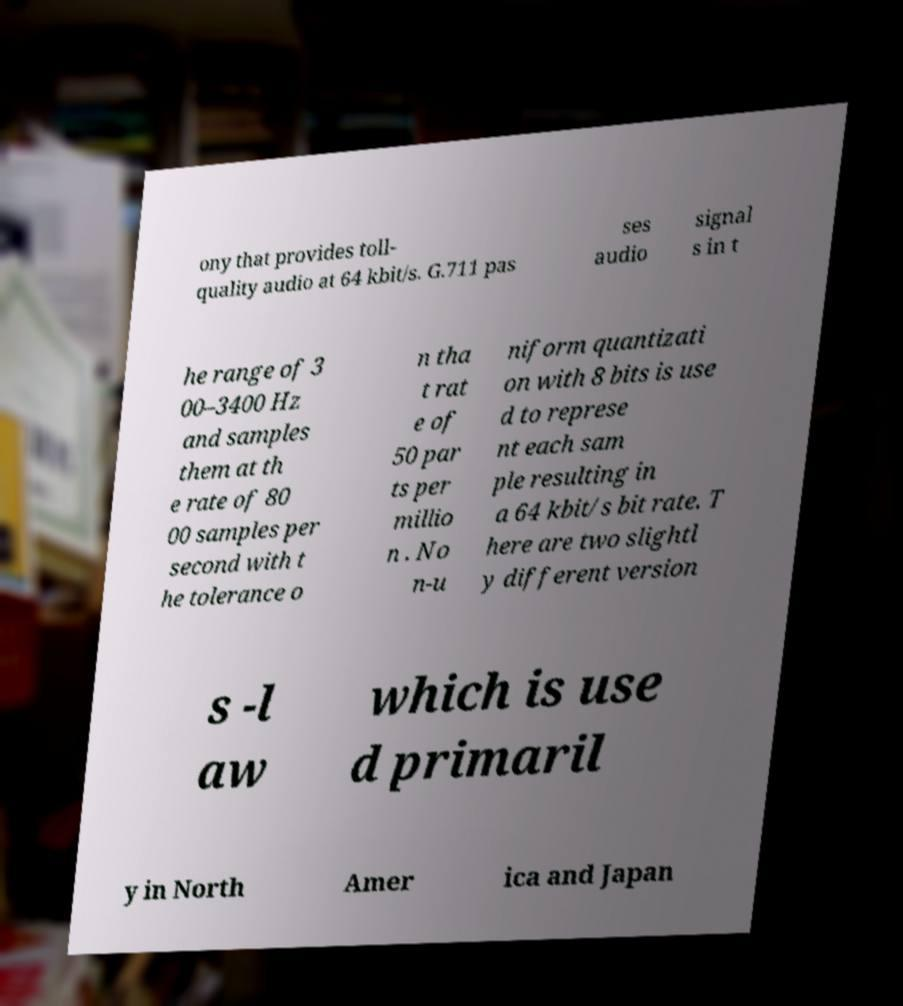Please read and relay the text visible in this image. What does it say? ony that provides toll- quality audio at 64 kbit/s. G.711 pas ses audio signal s in t he range of 3 00–3400 Hz and samples them at th e rate of 80 00 samples per second with t he tolerance o n tha t rat e of 50 par ts per millio n . No n-u niform quantizati on with 8 bits is use d to represe nt each sam ple resulting in a 64 kbit/s bit rate. T here are two slightl y different version s -l aw which is use d primaril y in North Amer ica and Japan 